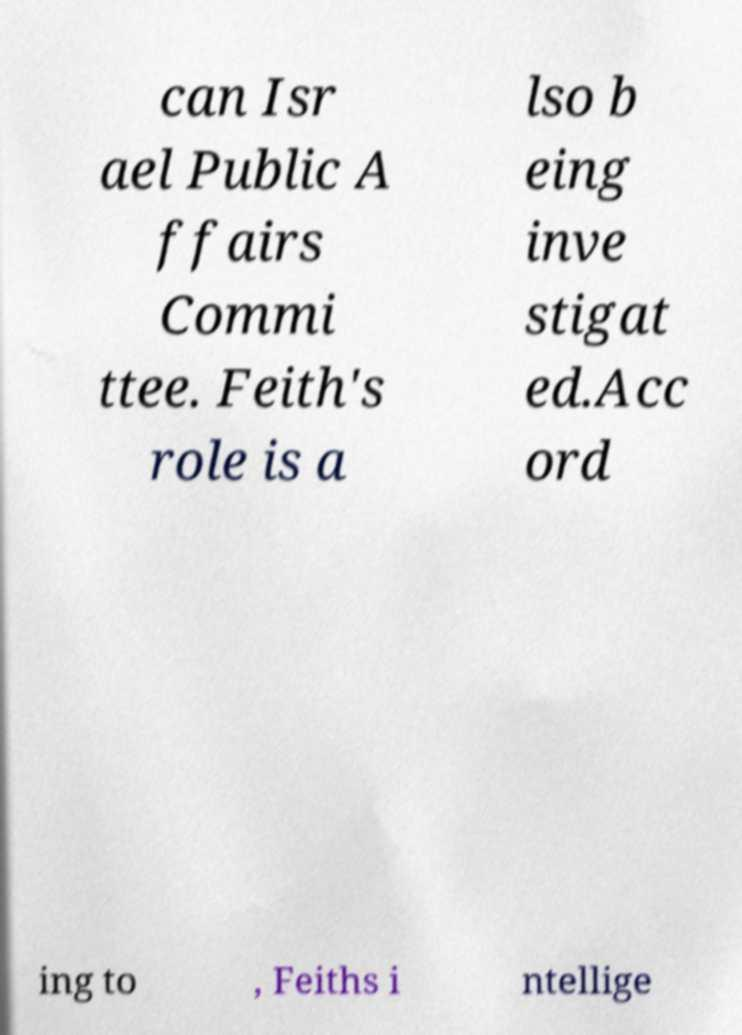Please read and relay the text visible in this image. What does it say? can Isr ael Public A ffairs Commi ttee. Feith's role is a lso b eing inve stigat ed.Acc ord ing to , Feiths i ntellige 